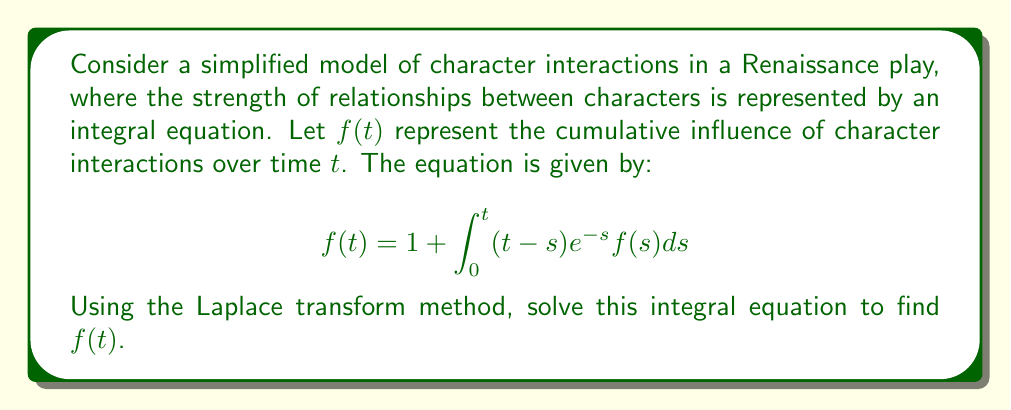Can you answer this question? Let's solve this step-by-step using the Laplace transform:

1) Let $F(s)$ be the Laplace transform of $f(t)$. Take the Laplace transform of both sides:

   $$\mathcal{L}\{f(t)\} = \mathcal{L}\{1\} + \mathcal{L}\{\int_0^t (t-s)e^{-s}f(s)ds\}$$

2) Using Laplace transform properties:

   $$F(s) = \frac{1}{s} + \mathcal{L}\{(t-s)e^{-s}\} \cdot F(s)$$

3) The Laplace transform of $(t-s)e^{-s}$ is $\frac{1}{(s+1)^2}$. So:

   $$F(s) = \frac{1}{s} + \frac{1}{(s+1)^2}F(s)$$

4) Rearrange the equation:

   $$F(s) - \frac{1}{(s+1)^2}F(s) = \frac{1}{s}$$

   $$F(s)(\frac{s^2+2s+1-(s+1)}{(s+1)^2}) = \frac{1}{s}$$

   $$F(s)(\frac{s^2+s}{(s+1)^2}) = \frac{1}{s}$$

5) Solve for $F(s)$:

   $$F(s) = \frac{(s+1)^2}{s^3+s^2}$$

6) Decompose into partial fractions:

   $$F(s) = \frac{1}{s} + \frac{2}{s^2} + \frac{1}{s^3}$$

7) Take the inverse Laplace transform:

   $$f(t) = \mathcal{L}^{-1}\{\frac{1}{s} + \frac{2}{s^2} + \frac{1}{s^3}\}$$

   $$f(t) = 1 + 2t + \frac{t^2}{2}$$

Thus, we have solved the integral equation for $f(t)$.
Answer: $f(t) = 1 + 2t + \frac{t^2}{2}$ 